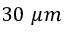<formula> <loc_0><loc_0><loc_500><loc_500>3 0 \mu m</formula> 